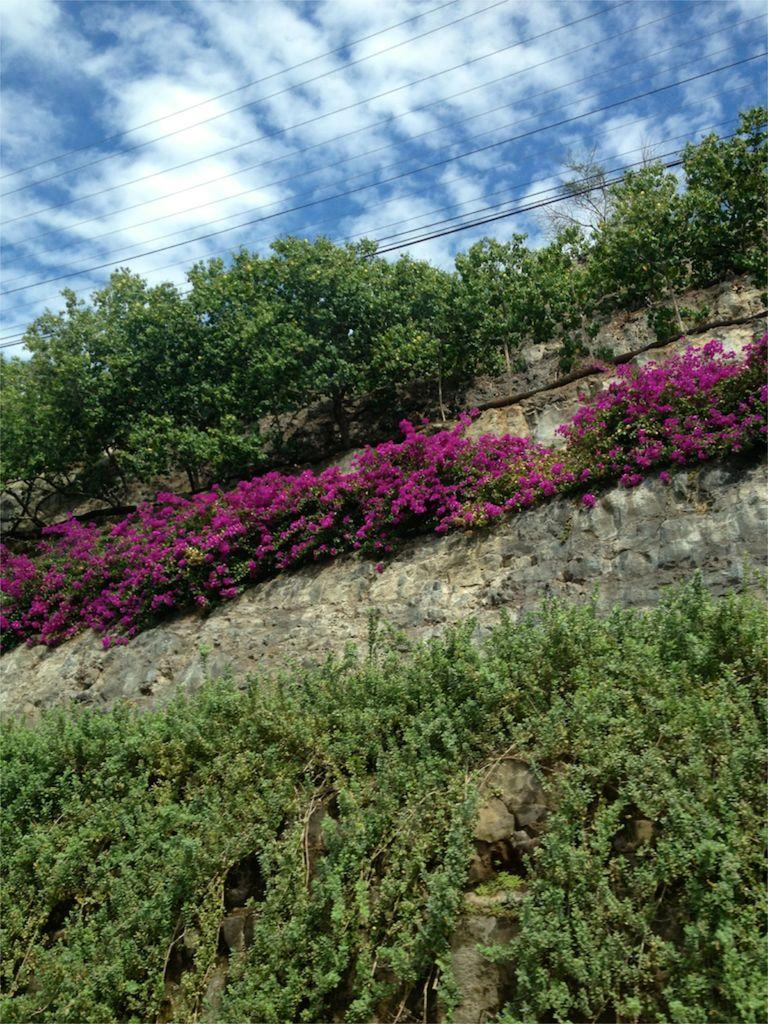What type of vegetation can be seen in the image? There are trees, plants, and flowers in the image. What type of structure is visible in the image? There is a brick wall in the image. What other man-made object can be seen in the image? There is an electrical cable in the image. What is visible at the top of the image? The sky is visible at the top of the image. What can be seen in the sky? Clouds are present in the sky. Can you hear the snail whistling in the image? There is no snail or whistling present in the image. What type of noise is coming from the electrical cable in the image? There is no noise coming from the electrical cable in the image; it is a stationary object. 